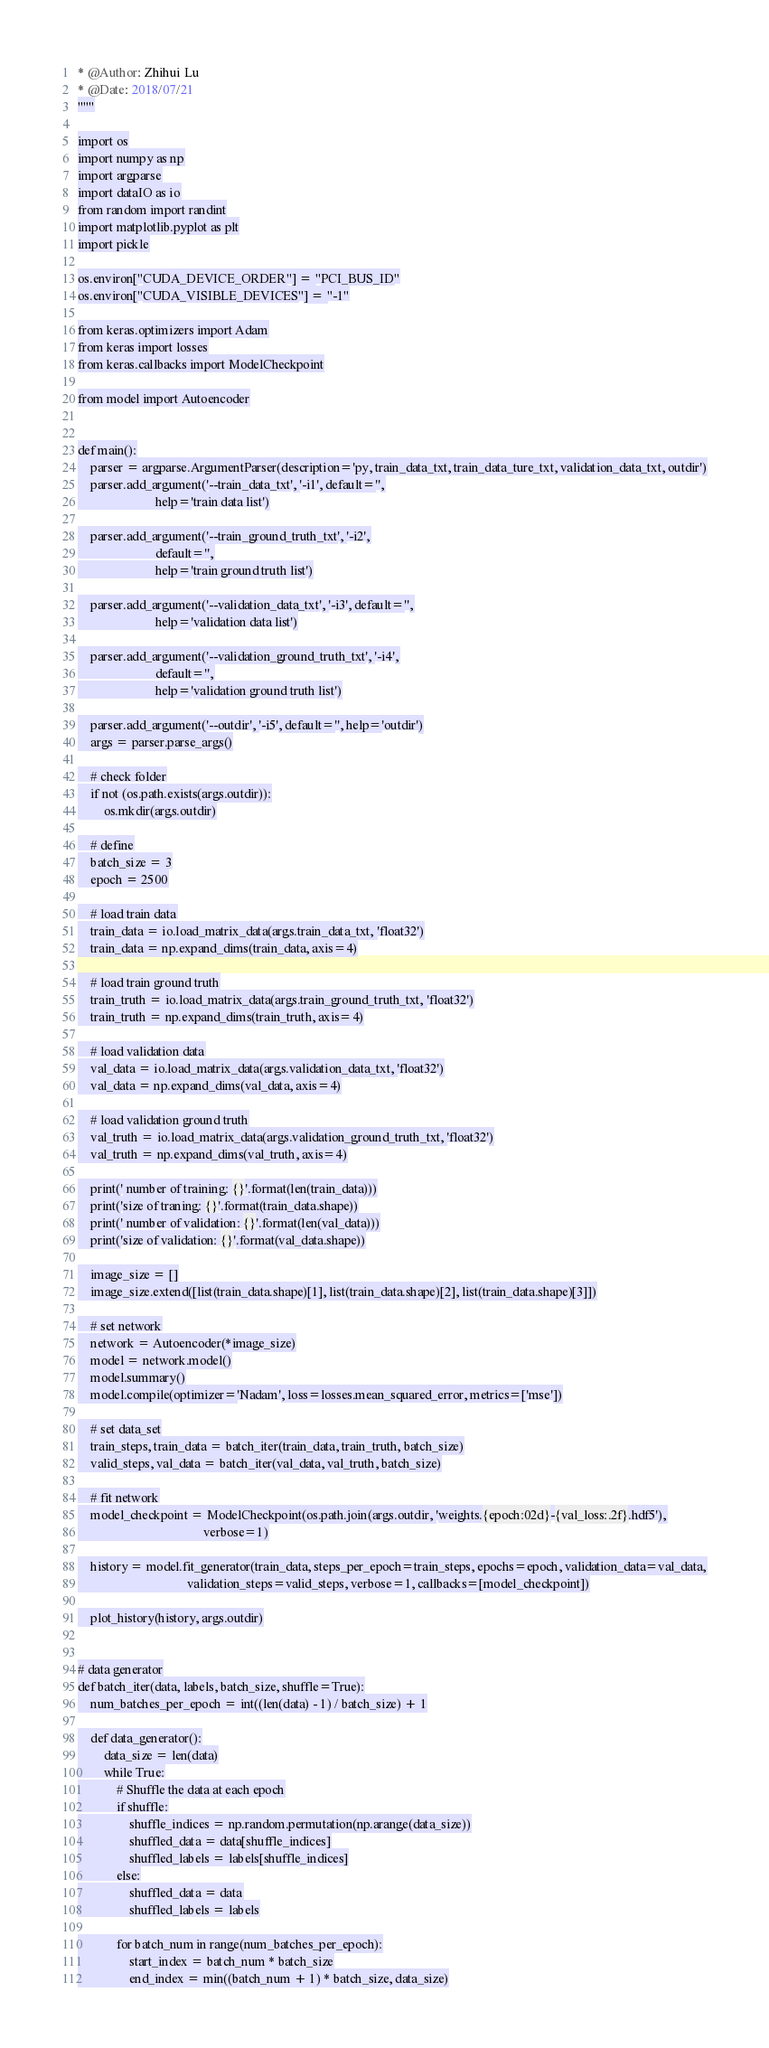Convert code to text. <code><loc_0><loc_0><loc_500><loc_500><_Python_>* @Author: Zhihui Lu
* @Date: 2018/07/21
"""

import os
import numpy as np
import argparse
import dataIO as io
from random import randint
import matplotlib.pyplot as plt
import pickle

os.environ["CUDA_DEVICE_ORDER"] = "PCI_BUS_ID"
os.environ["CUDA_VISIBLE_DEVICES"] = "-1"

from keras.optimizers import Adam
from keras import losses
from keras.callbacks import ModelCheckpoint

from model import Autoencoder


def main():
    parser = argparse.ArgumentParser(description='py, train_data_txt, train_data_ture_txt, validation_data_txt, outdir')
    parser.add_argument('--train_data_txt', '-i1', default='',
                        help='train data list')

    parser.add_argument('--train_ground_truth_txt', '-i2',
                        default='',
                        help='train ground truth list')

    parser.add_argument('--validation_data_txt', '-i3', default='',
                        help='validation data list')

    parser.add_argument('--validation_ground_truth_txt', '-i4',
                        default='',
                        help='validation ground truth list')

    parser.add_argument('--outdir', '-i5', default='', help='outdir')
    args = parser.parse_args()

    # check folder
    if not (os.path.exists(args.outdir)):
        os.mkdir(args.outdir)

    # define
    batch_size = 3
    epoch = 2500

    # load train data
    train_data = io.load_matrix_data(args.train_data_txt, 'float32')
    train_data = np.expand_dims(train_data, axis=4)

    # load train ground truth
    train_truth = io.load_matrix_data(args.train_ground_truth_txt, 'float32')
    train_truth = np.expand_dims(train_truth, axis=4)

    # load validation data
    val_data = io.load_matrix_data(args.validation_data_txt, 'float32')
    val_data = np.expand_dims(val_data, axis=4)

    # load validation ground truth
    val_truth = io.load_matrix_data(args.validation_ground_truth_txt, 'float32')
    val_truth = np.expand_dims(val_truth, axis=4)

    print(' number of training: {}'.format(len(train_data)))
    print('size of traning: {}'.format(train_data.shape))
    print(' number of validation: {}'.format(len(val_data)))
    print('size of validation: {}'.format(val_data.shape))

    image_size = []
    image_size.extend([list(train_data.shape)[1], list(train_data.shape)[2], list(train_data.shape)[3]])

    # set network
    network = Autoencoder(*image_size)
    model = network.model()
    model.summary()
    model.compile(optimizer='Nadam', loss=losses.mean_squared_error, metrics=['mse'])

    # set data_set
    train_steps, train_data = batch_iter(train_data, train_truth, batch_size)
    valid_steps, val_data = batch_iter(val_data, val_truth, batch_size)

    # fit network
    model_checkpoint = ModelCheckpoint(os.path.join(args.outdir, 'weights.{epoch:02d}-{val_loss:.2f}.hdf5'),
                                       verbose=1)

    history = model.fit_generator(train_data, steps_per_epoch=train_steps, epochs=epoch, validation_data=val_data,
                                  validation_steps=valid_steps, verbose=1, callbacks=[model_checkpoint])

    plot_history(history, args.outdir)


# data generator
def batch_iter(data, labels, batch_size, shuffle=True):
    num_batches_per_epoch = int((len(data) - 1) / batch_size) + 1

    def data_generator():
        data_size = len(data)
        while True:
            # Shuffle the data at each epoch
            if shuffle:
                shuffle_indices = np.random.permutation(np.arange(data_size))
                shuffled_data = data[shuffle_indices]
                shuffled_labels = labels[shuffle_indices]
            else:
                shuffled_data = data
                shuffled_labels = labels

            for batch_num in range(num_batches_per_epoch):
                start_index = batch_num * batch_size
                end_index = min((batch_num + 1) * batch_size, data_size)</code> 